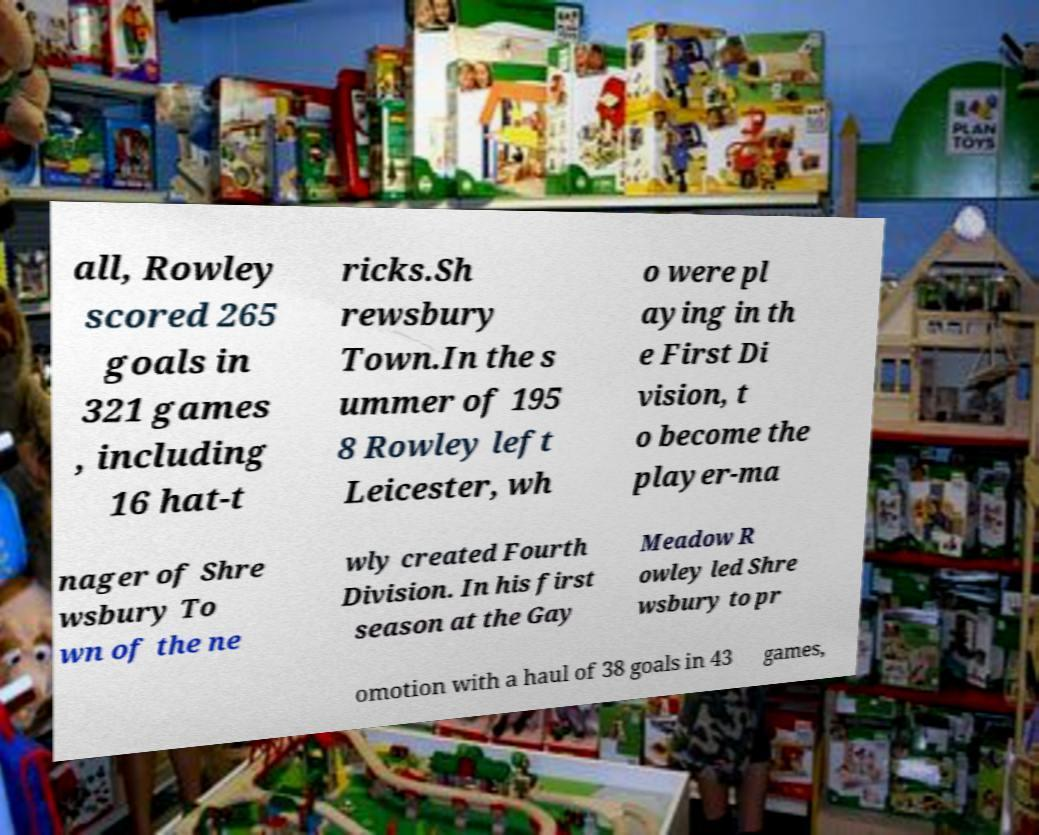For documentation purposes, I need the text within this image transcribed. Could you provide that? all, Rowley scored 265 goals in 321 games , including 16 hat-t ricks.Sh rewsbury Town.In the s ummer of 195 8 Rowley left Leicester, wh o were pl aying in th e First Di vision, t o become the player-ma nager of Shre wsbury To wn of the ne wly created Fourth Division. In his first season at the Gay Meadow R owley led Shre wsbury to pr omotion with a haul of 38 goals in 43 games, 